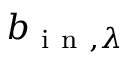Convert formula to latex. <formula><loc_0><loc_0><loc_500><loc_500>b _ { i n , \lambda }</formula> 